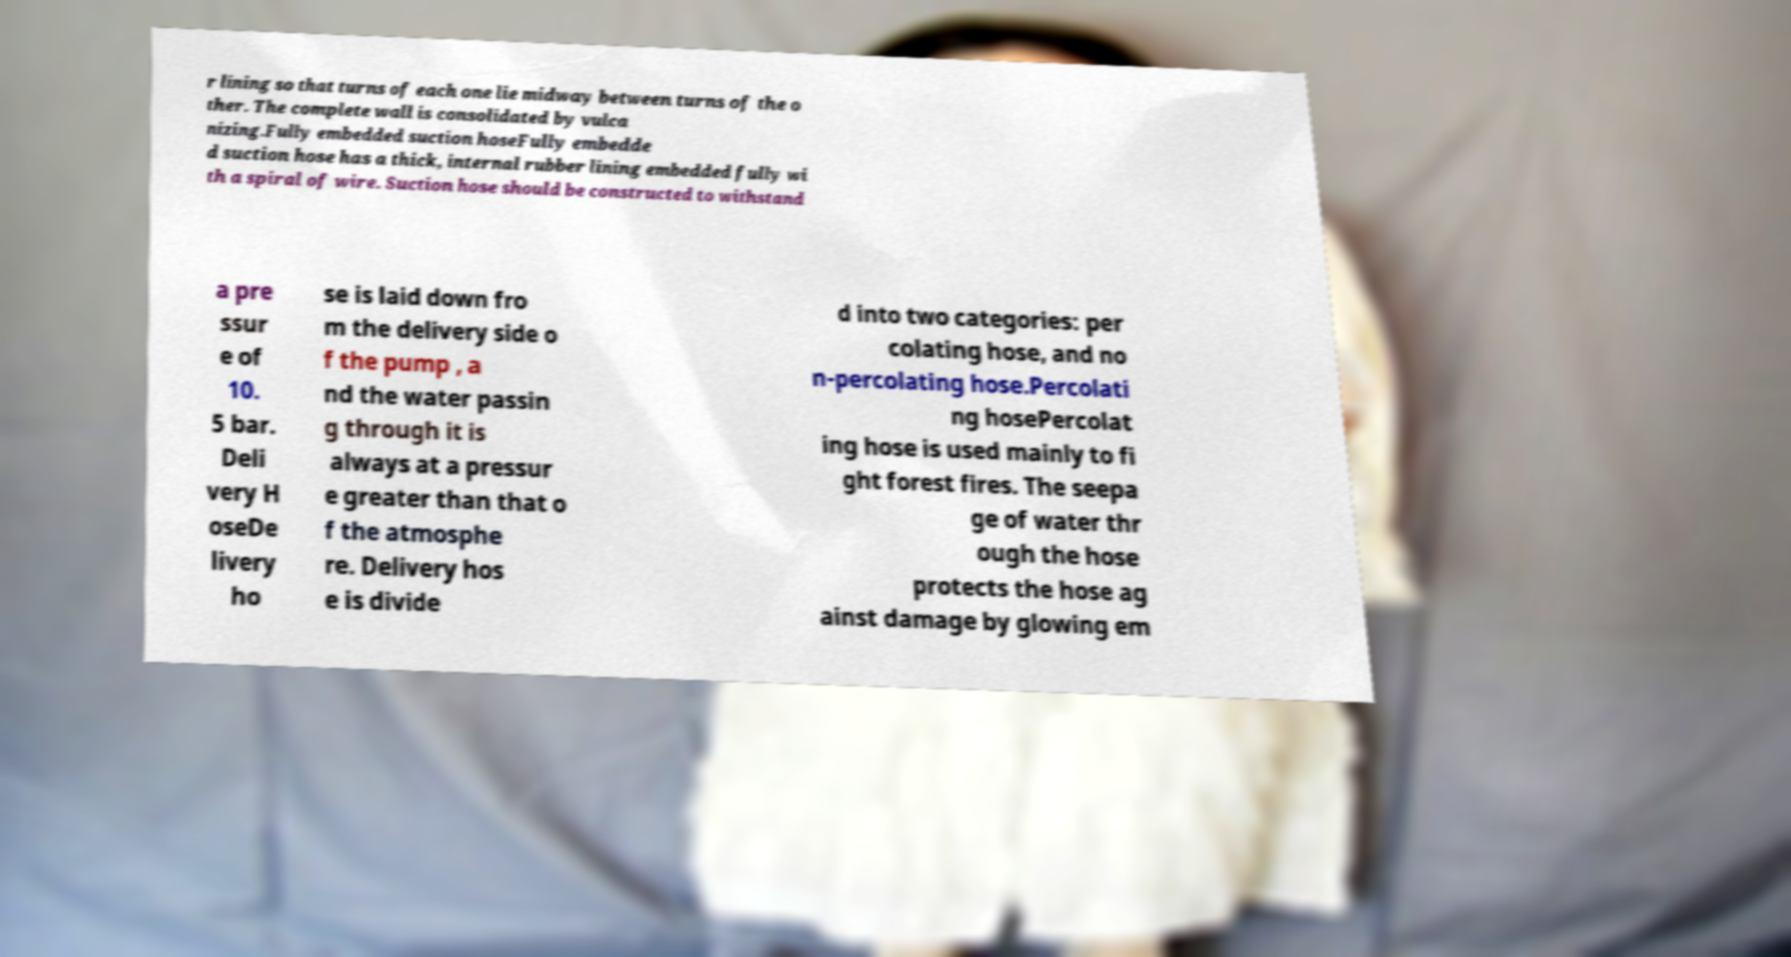Could you assist in decoding the text presented in this image and type it out clearly? r lining so that turns of each one lie midway between turns of the o ther. The complete wall is consolidated by vulca nizing.Fully embedded suction hoseFully embedde d suction hose has a thick, internal rubber lining embedded fully wi th a spiral of wire. Suction hose should be constructed to withstand a pre ssur e of 10. 5 bar. Deli very H oseDe livery ho se is laid down fro m the delivery side o f the pump , a nd the water passin g through it is always at a pressur e greater than that o f the atmosphe re. Delivery hos e is divide d into two categories: per colating hose, and no n-percolating hose.Percolati ng hosePercolat ing hose is used mainly to fi ght forest fires. The seepa ge of water thr ough the hose protects the hose ag ainst damage by glowing em 